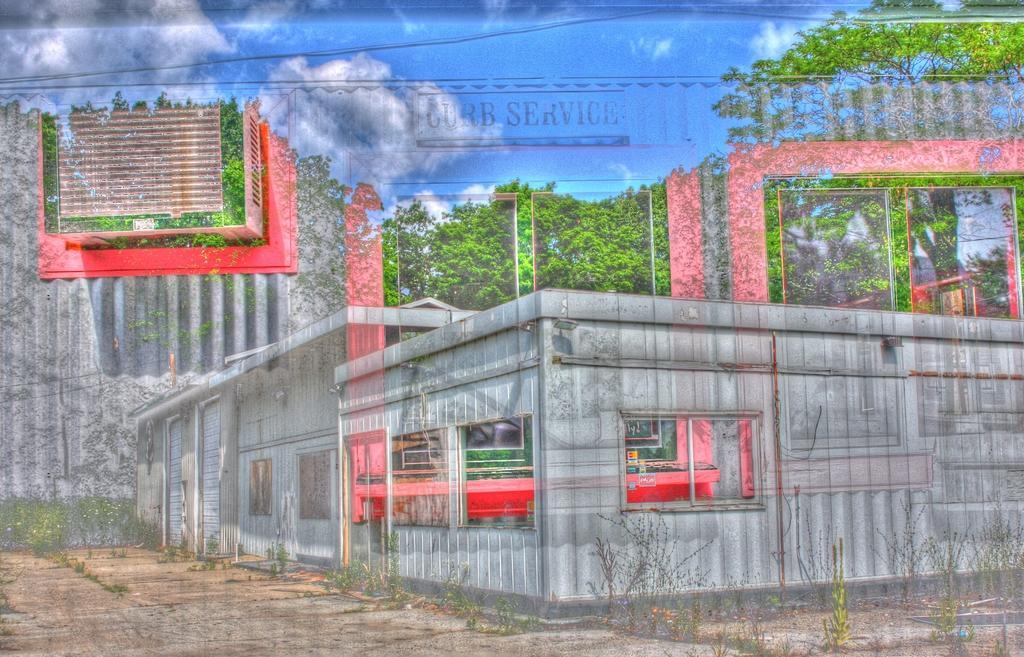How would you summarize this image in a sentence or two? In this image I can see the buildings, trees and clouds in the sky. 